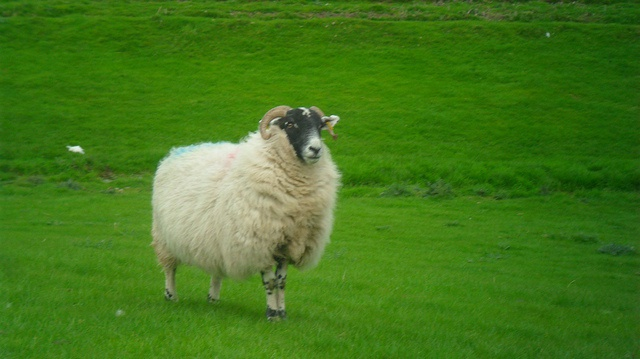Describe the objects in this image and their specific colors. I can see a sheep in darkgreen, olive, tan, and beige tones in this image. 